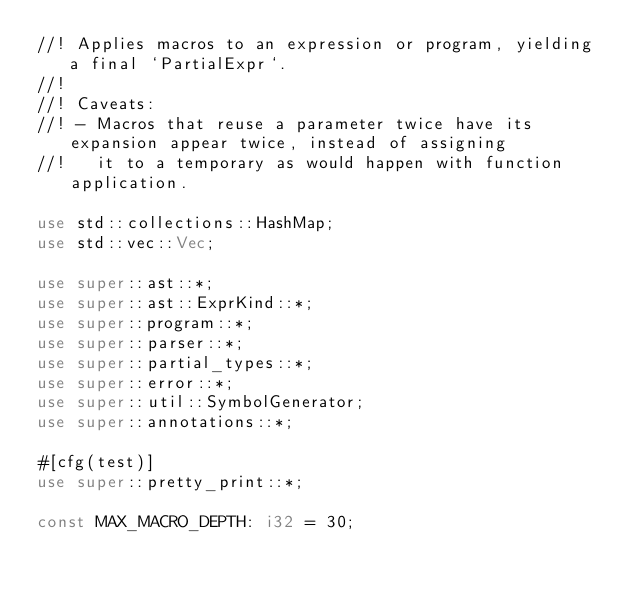<code> <loc_0><loc_0><loc_500><loc_500><_Rust_>//! Applies macros to an expression or program, yielding a final `PartialExpr`.
//!
//! Caveats:
//! - Macros that reuse a parameter twice have its expansion appear twice, instead of assigning
//!   it to a temporary as would happen with function application.

use std::collections::HashMap;
use std::vec::Vec;

use super::ast::*;
use super::ast::ExprKind::*;
use super::program::*;
use super::parser::*;
use super::partial_types::*;
use super::error::*;
use super::util::SymbolGenerator;
use super::annotations::*;

#[cfg(test)]
use super::pretty_print::*;

const MAX_MACRO_DEPTH: i32 = 30;
</code> 